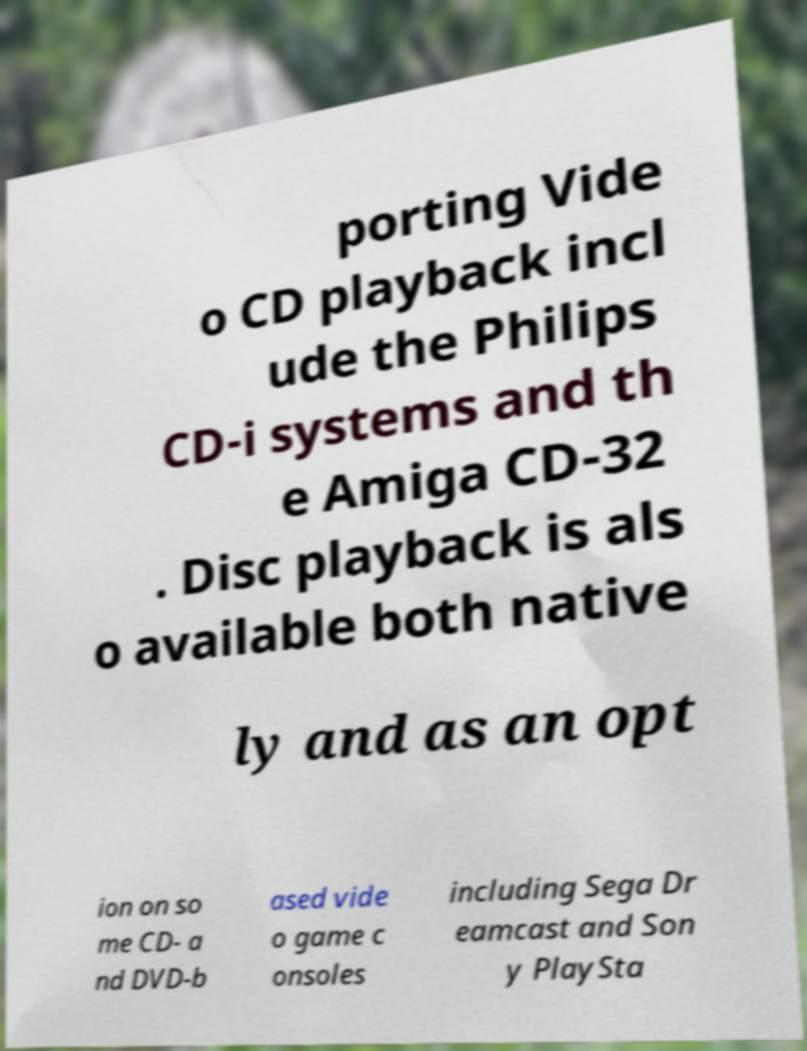Please read and relay the text visible in this image. What does it say? porting Vide o CD playback incl ude the Philips CD-i systems and th e Amiga CD-32 . Disc playback is als o available both native ly and as an opt ion on so me CD- a nd DVD-b ased vide o game c onsoles including Sega Dr eamcast and Son y PlaySta 